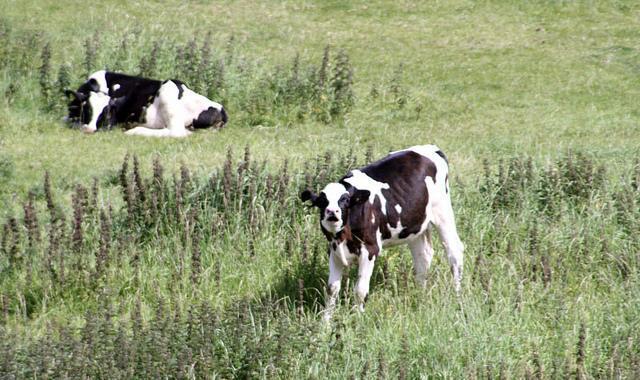How many cows can you see?
Give a very brief answer. 2. 